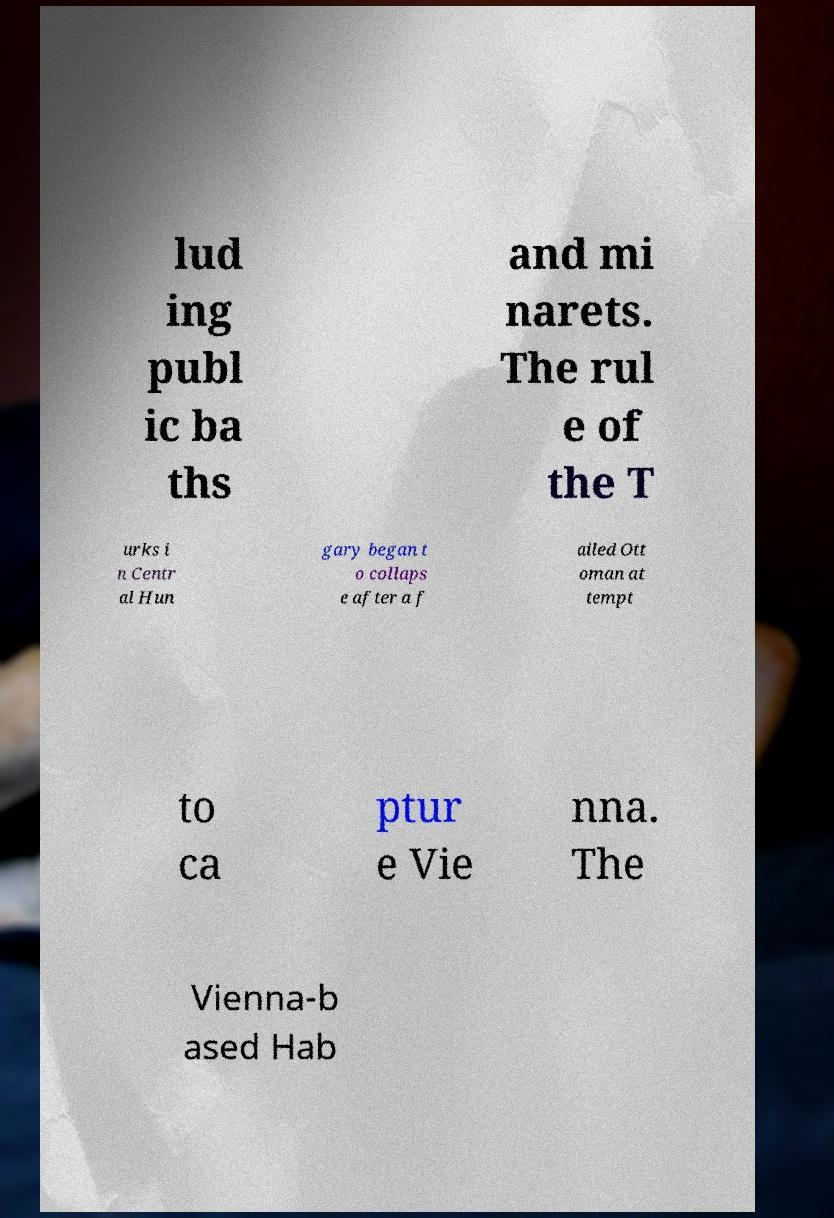There's text embedded in this image that I need extracted. Can you transcribe it verbatim? lud ing publ ic ba ths and mi narets. The rul e of the T urks i n Centr al Hun gary began t o collaps e after a f ailed Ott oman at tempt to ca ptur e Vie nna. The Vienna-b ased Hab 